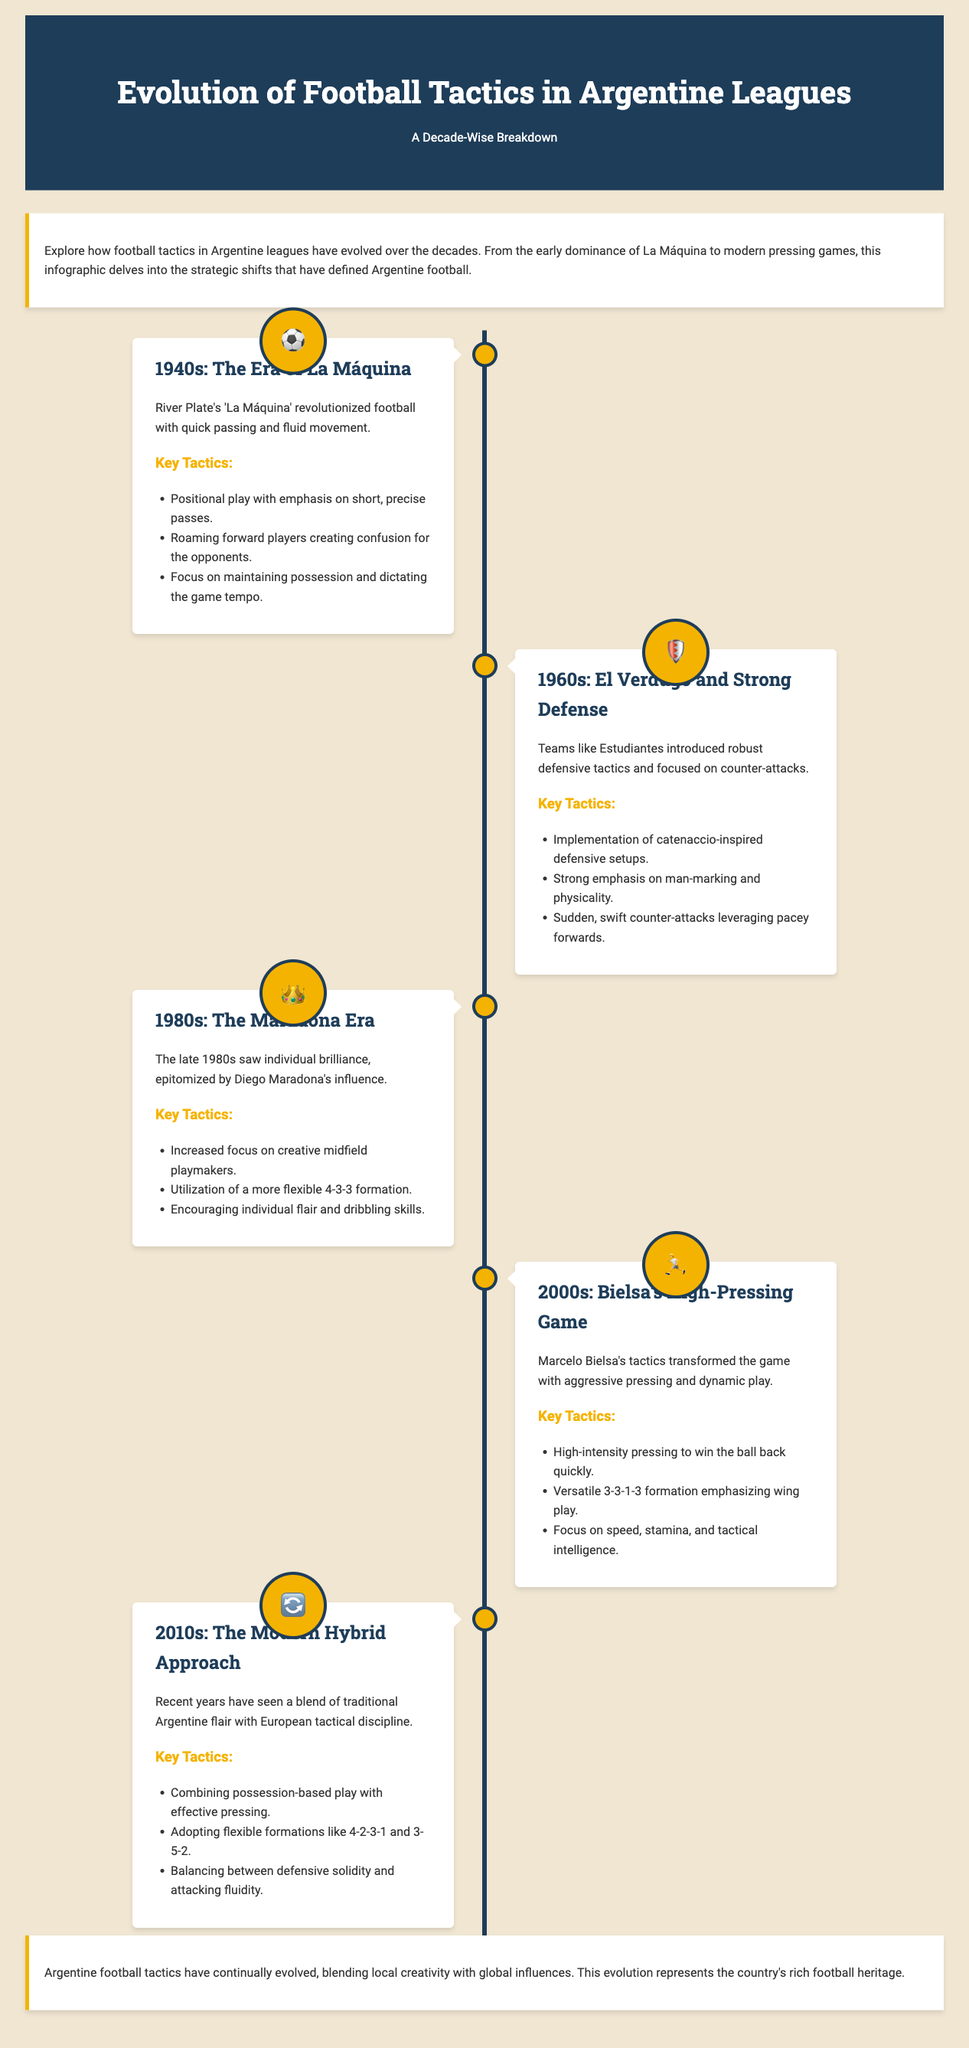What is the decade of La Máquina? La Máquina refers to the football period defined in the 1940s in the document.
Answer: 1940s Which team is associated with strong defensive tactics in the 1960s? The document mentions Estudiantes as the team that introduced strong defensive tactics during the 1960s.
Answer: Estudiantes What tactical approach is highlighted in the 2000s? The 2000s featured Marcelo Bielsa's high-pressing game according to the document.
Answer: Bielsa's High-Pressing Game What is the key tactical formation in the 1980s? The document states that a more flexible 4-3-3 formation was utilized during the 1980s.
Answer: 4-3-3 What year marks the emergence of the modern hybrid approach? The 2010s are identified in the document as the period for the modern hybrid approach.
Answer: 2010s What is a key tactic from the 1940s? The focus of the 1940s tactics included maintaining possession and dictating the game tempo, as outlined in the document.
Answer: Maintaining possession Which player is prominently mentioned in the 1980s? Diego Maradona is the individual whose influence is discussed during the 1980s in the document.
Answer: Diego Maradona What is the significance of the 2010s in tactical evolution? The 2010s represent a blend of traditional Argentine flair with European tactical discipline as stated in the document.
Answer: Blend of flair and discipline What type of icon represents the 2000s? The icon associated with the 2000s is a running person emoji.
Answer: 🏃 